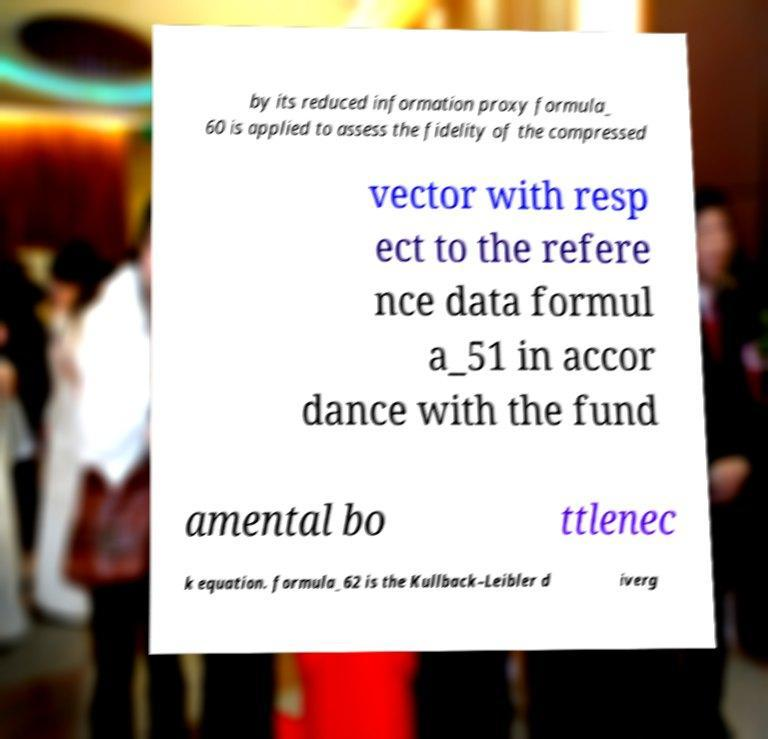There's text embedded in this image that I need extracted. Can you transcribe it verbatim? by its reduced information proxy formula_ 60 is applied to assess the fidelity of the compressed vector with resp ect to the refere nce data formul a_51 in accor dance with the fund amental bo ttlenec k equation. formula_62 is the Kullback–Leibler d iverg 